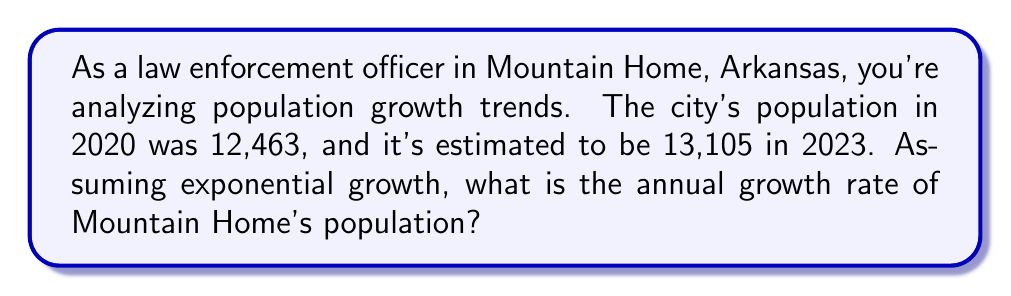Teach me how to tackle this problem. To solve this problem, we'll use the exponential growth formula:

$$ P(t) = P_0 \cdot e^{rt} $$

Where:
$P(t)$ is the population at time $t$
$P_0$ is the initial population
$r$ is the annual growth rate
$t$ is the time in years

Step 1: Identify the known values
$P_0 = 12,463$ (population in 2020)
$P(t) = 13,105$ (population in 2023)
$t = 3$ years

Step 2: Plug these values into the formula
$$ 13,105 = 12,463 \cdot e^{3r} $$

Step 3: Solve for $r$
Divide both sides by 12,463:
$$ \frac{13,105}{12,463} = e^{3r} $$

Take the natural log of both sides:
$$ \ln(\frac{13,105}{12,463}) = 3r $$

Divide both sides by 3:
$$ r = \frac{\ln(\frac{13,105}{12,463})}{3} $$

Step 4: Calculate the result
$$ r = \frac{\ln(1.0514)}{3} \approx 0.0168 $$

Step 5: Convert to a percentage
$0.0168 \times 100\% = 1.68\%$
Answer: 1.68% 